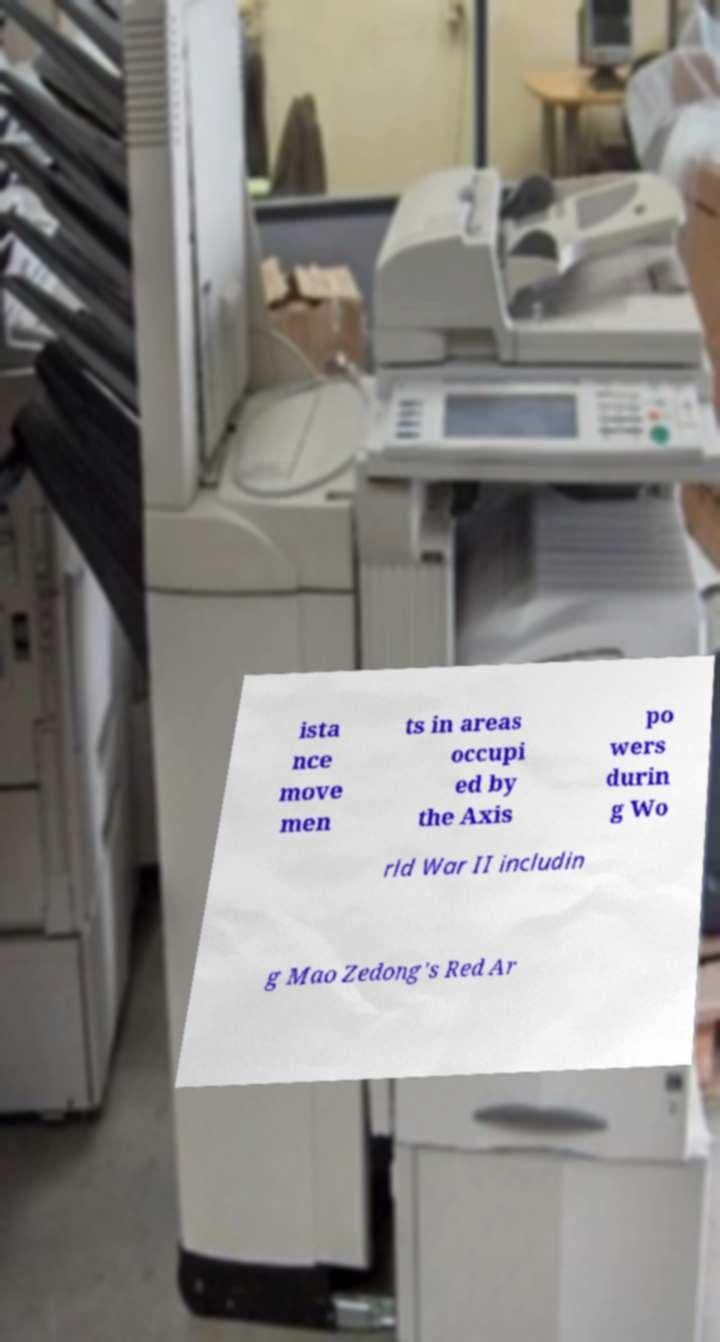Could you assist in decoding the text presented in this image and type it out clearly? ista nce move men ts in areas occupi ed by the Axis po wers durin g Wo rld War II includin g Mao Zedong's Red Ar 